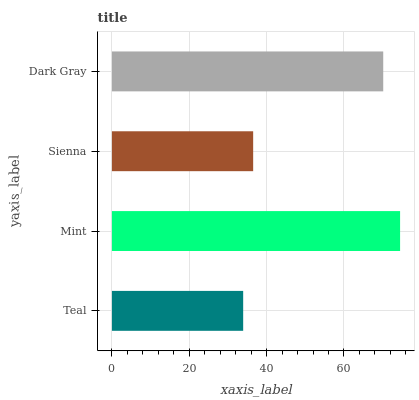Is Teal the minimum?
Answer yes or no. Yes. Is Mint the maximum?
Answer yes or no. Yes. Is Sienna the minimum?
Answer yes or no. No. Is Sienna the maximum?
Answer yes or no. No. Is Mint greater than Sienna?
Answer yes or no. Yes. Is Sienna less than Mint?
Answer yes or no. Yes. Is Sienna greater than Mint?
Answer yes or no. No. Is Mint less than Sienna?
Answer yes or no. No. Is Dark Gray the high median?
Answer yes or no. Yes. Is Sienna the low median?
Answer yes or no. Yes. Is Sienna the high median?
Answer yes or no. No. Is Dark Gray the low median?
Answer yes or no. No. 